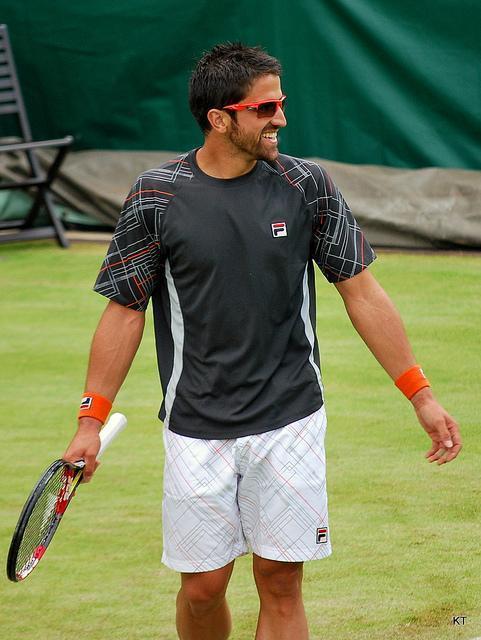How many people in the picture?
Give a very brief answer. 1. How many men are there?
Give a very brief answer. 1. 